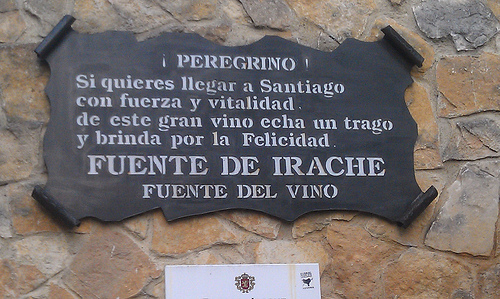<image>
Is there a crack to the right of the letters? No. The crack is not to the right of the letters. The horizontal positioning shows a different relationship. 